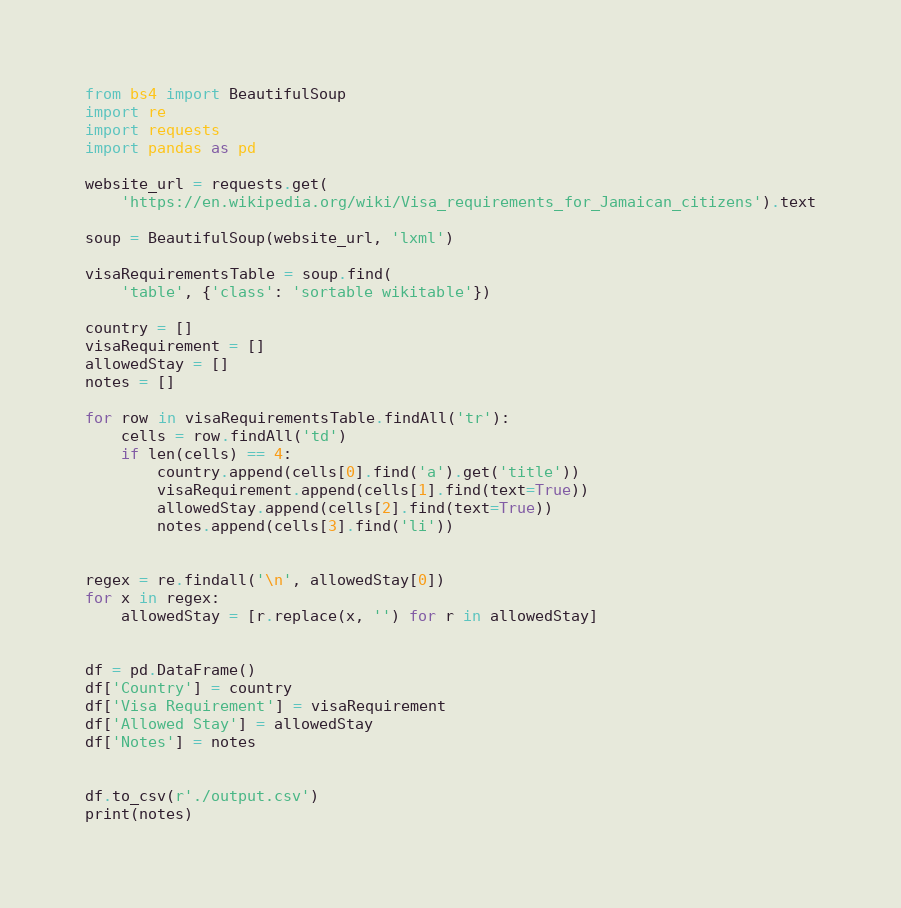Convert code to text. <code><loc_0><loc_0><loc_500><loc_500><_Python_>from bs4 import BeautifulSoup
import re
import requests
import pandas as pd

website_url = requests.get(
    'https://en.wikipedia.org/wiki/Visa_requirements_for_Jamaican_citizens').text

soup = BeautifulSoup(website_url, 'lxml')

visaRequirementsTable = soup.find(
    'table', {'class': 'sortable wikitable'})

country = []
visaRequirement = []
allowedStay = []
notes = []

for row in visaRequirementsTable.findAll('tr'):
    cells = row.findAll('td')
    if len(cells) == 4:
        country.append(cells[0].find('a').get('title'))
        visaRequirement.append(cells[1].find(text=True))
        allowedStay.append(cells[2].find(text=True))
        notes.append(cells[3].find('li'))


regex = re.findall('\n', allowedStay[0])
for x in regex:
    allowedStay = [r.replace(x, '') for r in allowedStay]


df = pd.DataFrame()
df['Country'] = country
df['Visa Requirement'] = visaRequirement
df['Allowed Stay'] = allowedStay
df['Notes'] = notes


df.to_csv(r'./output.csv')
print(notes)
</code> 